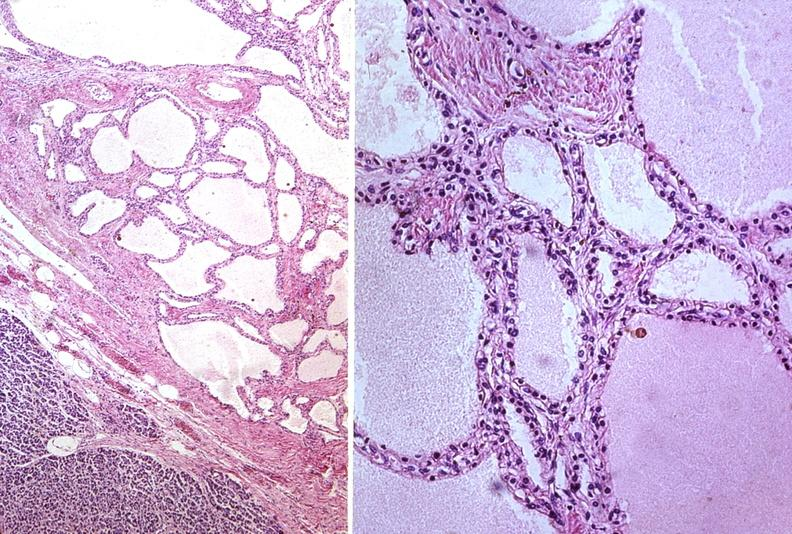where is this?
Answer the question using a single word or phrase. Pancreas 